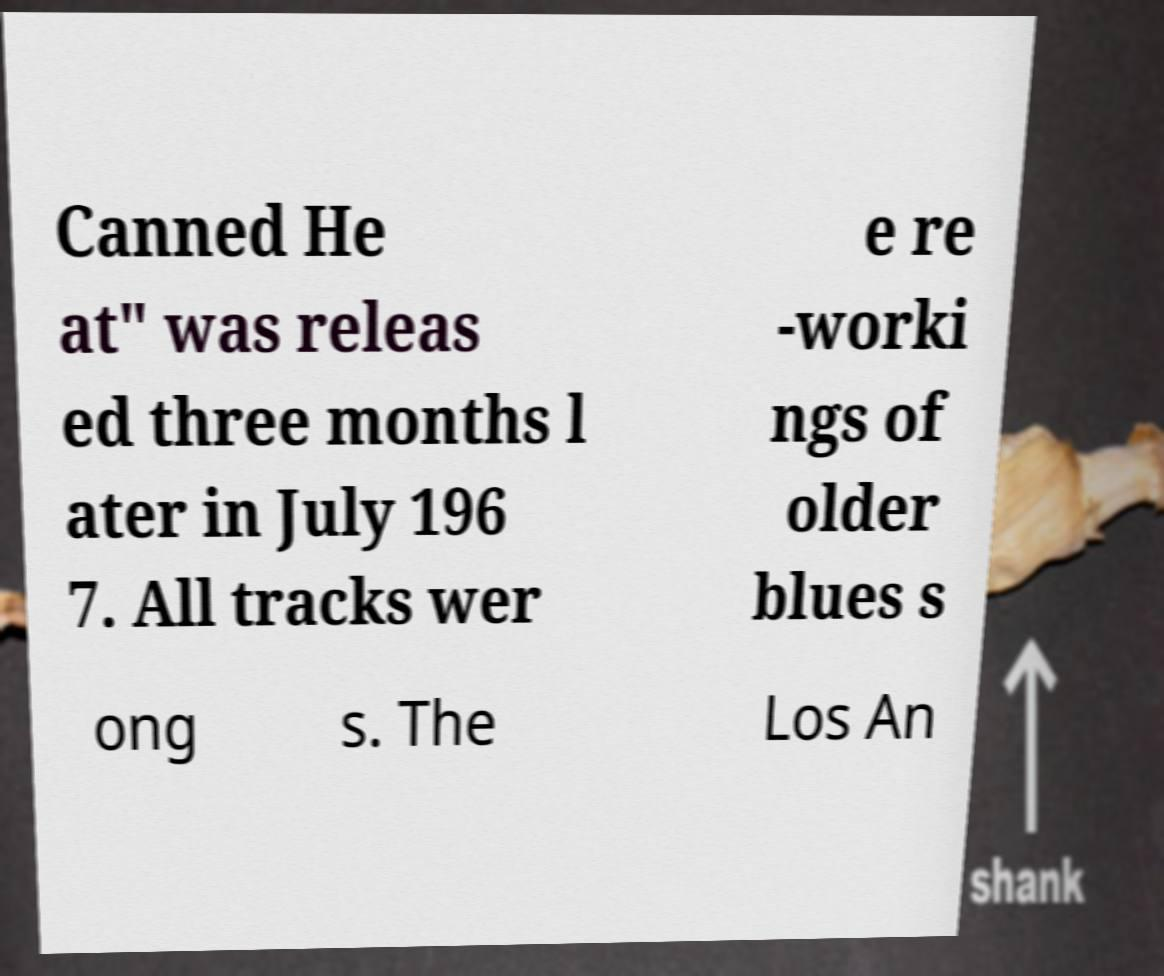Can you read and provide the text displayed in the image?This photo seems to have some interesting text. Can you extract and type it out for me? Canned He at" was releas ed three months l ater in July 196 7. All tracks wer e re -worki ngs of older blues s ong s. The Los An 